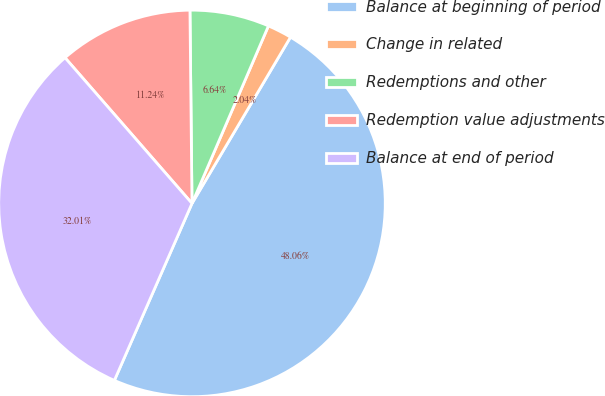Convert chart to OTSL. <chart><loc_0><loc_0><loc_500><loc_500><pie_chart><fcel>Balance at beginning of period<fcel>Change in related<fcel>Redemptions and other<fcel>Redemption value adjustments<fcel>Balance at end of period<nl><fcel>48.06%<fcel>2.04%<fcel>6.64%<fcel>11.24%<fcel>32.01%<nl></chart> 